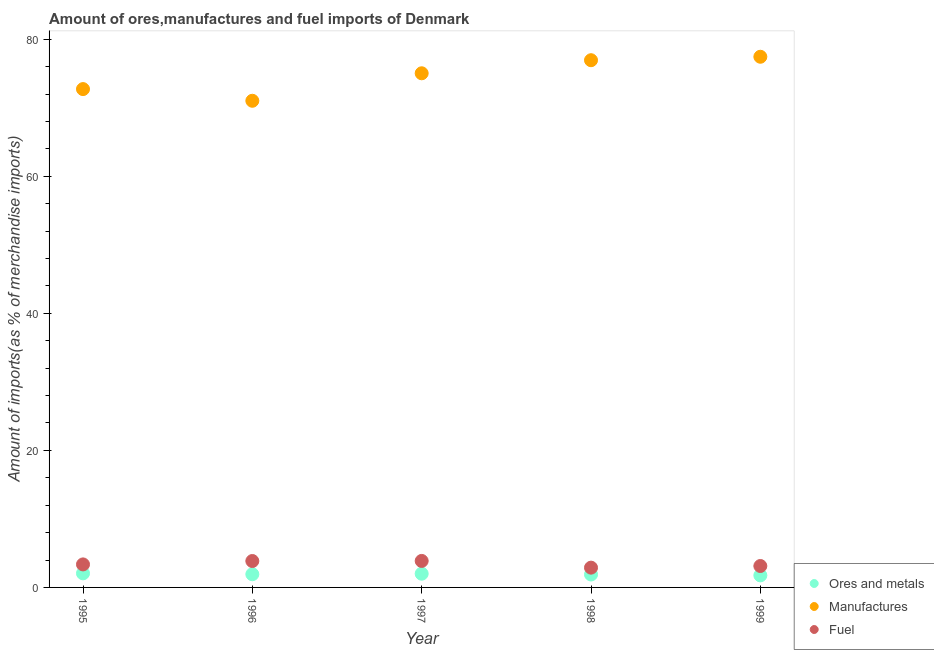What is the percentage of manufactures imports in 1997?
Ensure brevity in your answer.  75.02. Across all years, what is the maximum percentage of fuel imports?
Offer a terse response. 3.87. Across all years, what is the minimum percentage of manufactures imports?
Keep it short and to the point. 71.01. In which year was the percentage of fuel imports maximum?
Offer a terse response. 1997. What is the total percentage of manufactures imports in the graph?
Give a very brief answer. 373.12. What is the difference between the percentage of manufactures imports in 1995 and that in 1998?
Give a very brief answer. -4.21. What is the difference between the percentage of ores and metals imports in 1999 and the percentage of manufactures imports in 1995?
Your answer should be compact. -70.96. What is the average percentage of manufactures imports per year?
Your answer should be compact. 74.62. In the year 1999, what is the difference between the percentage of ores and metals imports and percentage of fuel imports?
Your answer should be very brief. -1.37. What is the ratio of the percentage of fuel imports in 1996 to that in 1997?
Offer a terse response. 1. What is the difference between the highest and the second highest percentage of manufactures imports?
Make the answer very short. 0.51. What is the difference between the highest and the lowest percentage of fuel imports?
Offer a terse response. 0.98. In how many years, is the percentage of fuel imports greater than the average percentage of fuel imports taken over all years?
Keep it short and to the point. 2. Is the sum of the percentage of fuel imports in 1996 and 1998 greater than the maximum percentage of manufactures imports across all years?
Ensure brevity in your answer.  No. Is it the case that in every year, the sum of the percentage of ores and metals imports and percentage of manufactures imports is greater than the percentage of fuel imports?
Your answer should be very brief. Yes. How many dotlines are there?
Give a very brief answer. 3. How many years are there in the graph?
Give a very brief answer. 5. Are the values on the major ticks of Y-axis written in scientific E-notation?
Make the answer very short. No. Does the graph contain grids?
Your answer should be very brief. No. How many legend labels are there?
Give a very brief answer. 3. What is the title of the graph?
Provide a short and direct response. Amount of ores,manufactures and fuel imports of Denmark. Does "Agriculture" appear as one of the legend labels in the graph?
Offer a terse response. No. What is the label or title of the Y-axis?
Your answer should be very brief. Amount of imports(as % of merchandise imports). What is the Amount of imports(as % of merchandise imports) of Ores and metals in 1995?
Your response must be concise. 2.05. What is the Amount of imports(as % of merchandise imports) in Manufactures in 1995?
Your answer should be very brief. 72.72. What is the Amount of imports(as % of merchandise imports) of Fuel in 1995?
Keep it short and to the point. 3.36. What is the Amount of imports(as % of merchandise imports) in Ores and metals in 1996?
Provide a succinct answer. 1.92. What is the Amount of imports(as % of merchandise imports) of Manufactures in 1996?
Provide a succinct answer. 71.01. What is the Amount of imports(as % of merchandise imports) in Fuel in 1996?
Offer a very short reply. 3.85. What is the Amount of imports(as % of merchandise imports) of Ores and metals in 1997?
Your response must be concise. 2. What is the Amount of imports(as % of merchandise imports) of Manufactures in 1997?
Offer a very short reply. 75.02. What is the Amount of imports(as % of merchandise imports) of Fuel in 1997?
Your answer should be very brief. 3.87. What is the Amount of imports(as % of merchandise imports) in Ores and metals in 1998?
Offer a very short reply. 1.89. What is the Amount of imports(as % of merchandise imports) in Manufactures in 1998?
Offer a terse response. 76.93. What is the Amount of imports(as % of merchandise imports) of Fuel in 1998?
Offer a very short reply. 2.89. What is the Amount of imports(as % of merchandise imports) in Ores and metals in 1999?
Make the answer very short. 1.76. What is the Amount of imports(as % of merchandise imports) in Manufactures in 1999?
Provide a succinct answer. 77.44. What is the Amount of imports(as % of merchandise imports) in Fuel in 1999?
Make the answer very short. 3.12. Across all years, what is the maximum Amount of imports(as % of merchandise imports) of Ores and metals?
Offer a very short reply. 2.05. Across all years, what is the maximum Amount of imports(as % of merchandise imports) in Manufactures?
Offer a very short reply. 77.44. Across all years, what is the maximum Amount of imports(as % of merchandise imports) in Fuel?
Your answer should be compact. 3.87. Across all years, what is the minimum Amount of imports(as % of merchandise imports) in Ores and metals?
Your response must be concise. 1.76. Across all years, what is the minimum Amount of imports(as % of merchandise imports) of Manufactures?
Offer a terse response. 71.01. Across all years, what is the minimum Amount of imports(as % of merchandise imports) in Fuel?
Provide a short and direct response. 2.89. What is the total Amount of imports(as % of merchandise imports) of Ores and metals in the graph?
Provide a short and direct response. 9.62. What is the total Amount of imports(as % of merchandise imports) in Manufactures in the graph?
Give a very brief answer. 373.12. What is the total Amount of imports(as % of merchandise imports) in Fuel in the graph?
Provide a succinct answer. 17.09. What is the difference between the Amount of imports(as % of merchandise imports) of Ores and metals in 1995 and that in 1996?
Make the answer very short. 0.13. What is the difference between the Amount of imports(as % of merchandise imports) of Manufactures in 1995 and that in 1996?
Your answer should be compact. 1.71. What is the difference between the Amount of imports(as % of merchandise imports) of Fuel in 1995 and that in 1996?
Give a very brief answer. -0.49. What is the difference between the Amount of imports(as % of merchandise imports) of Ores and metals in 1995 and that in 1997?
Ensure brevity in your answer.  0.05. What is the difference between the Amount of imports(as % of merchandise imports) of Manufactures in 1995 and that in 1997?
Offer a very short reply. -2.31. What is the difference between the Amount of imports(as % of merchandise imports) of Fuel in 1995 and that in 1997?
Make the answer very short. -0.51. What is the difference between the Amount of imports(as % of merchandise imports) of Ores and metals in 1995 and that in 1998?
Provide a short and direct response. 0.17. What is the difference between the Amount of imports(as % of merchandise imports) of Manufactures in 1995 and that in 1998?
Give a very brief answer. -4.21. What is the difference between the Amount of imports(as % of merchandise imports) in Fuel in 1995 and that in 1998?
Ensure brevity in your answer.  0.47. What is the difference between the Amount of imports(as % of merchandise imports) of Ores and metals in 1995 and that in 1999?
Give a very brief answer. 0.29. What is the difference between the Amount of imports(as % of merchandise imports) of Manufactures in 1995 and that in 1999?
Offer a very short reply. -4.72. What is the difference between the Amount of imports(as % of merchandise imports) in Fuel in 1995 and that in 1999?
Give a very brief answer. 0.23. What is the difference between the Amount of imports(as % of merchandise imports) in Ores and metals in 1996 and that in 1997?
Offer a terse response. -0.08. What is the difference between the Amount of imports(as % of merchandise imports) in Manufactures in 1996 and that in 1997?
Your answer should be very brief. -4.01. What is the difference between the Amount of imports(as % of merchandise imports) of Fuel in 1996 and that in 1997?
Ensure brevity in your answer.  -0.01. What is the difference between the Amount of imports(as % of merchandise imports) in Ores and metals in 1996 and that in 1998?
Your response must be concise. 0.04. What is the difference between the Amount of imports(as % of merchandise imports) of Manufactures in 1996 and that in 1998?
Give a very brief answer. -5.92. What is the difference between the Amount of imports(as % of merchandise imports) of Fuel in 1996 and that in 1998?
Offer a terse response. 0.97. What is the difference between the Amount of imports(as % of merchandise imports) of Ores and metals in 1996 and that in 1999?
Your answer should be very brief. 0.16. What is the difference between the Amount of imports(as % of merchandise imports) of Manufactures in 1996 and that in 1999?
Offer a very short reply. -6.42. What is the difference between the Amount of imports(as % of merchandise imports) of Fuel in 1996 and that in 1999?
Keep it short and to the point. 0.73. What is the difference between the Amount of imports(as % of merchandise imports) of Ores and metals in 1997 and that in 1998?
Provide a succinct answer. 0.12. What is the difference between the Amount of imports(as % of merchandise imports) in Manufactures in 1997 and that in 1998?
Make the answer very short. -1.91. What is the difference between the Amount of imports(as % of merchandise imports) of Fuel in 1997 and that in 1998?
Provide a succinct answer. 0.98. What is the difference between the Amount of imports(as % of merchandise imports) of Ores and metals in 1997 and that in 1999?
Provide a short and direct response. 0.24. What is the difference between the Amount of imports(as % of merchandise imports) of Manufactures in 1997 and that in 1999?
Provide a succinct answer. -2.41. What is the difference between the Amount of imports(as % of merchandise imports) in Fuel in 1997 and that in 1999?
Your answer should be very brief. 0.74. What is the difference between the Amount of imports(as % of merchandise imports) of Ores and metals in 1998 and that in 1999?
Offer a terse response. 0.13. What is the difference between the Amount of imports(as % of merchandise imports) in Manufactures in 1998 and that in 1999?
Your response must be concise. -0.51. What is the difference between the Amount of imports(as % of merchandise imports) of Fuel in 1998 and that in 1999?
Make the answer very short. -0.24. What is the difference between the Amount of imports(as % of merchandise imports) of Ores and metals in 1995 and the Amount of imports(as % of merchandise imports) of Manufactures in 1996?
Offer a terse response. -68.96. What is the difference between the Amount of imports(as % of merchandise imports) in Ores and metals in 1995 and the Amount of imports(as % of merchandise imports) in Fuel in 1996?
Offer a terse response. -1.8. What is the difference between the Amount of imports(as % of merchandise imports) in Manufactures in 1995 and the Amount of imports(as % of merchandise imports) in Fuel in 1996?
Give a very brief answer. 68.86. What is the difference between the Amount of imports(as % of merchandise imports) of Ores and metals in 1995 and the Amount of imports(as % of merchandise imports) of Manufactures in 1997?
Keep it short and to the point. -72.97. What is the difference between the Amount of imports(as % of merchandise imports) of Ores and metals in 1995 and the Amount of imports(as % of merchandise imports) of Fuel in 1997?
Provide a succinct answer. -1.81. What is the difference between the Amount of imports(as % of merchandise imports) of Manufactures in 1995 and the Amount of imports(as % of merchandise imports) of Fuel in 1997?
Keep it short and to the point. 68.85. What is the difference between the Amount of imports(as % of merchandise imports) in Ores and metals in 1995 and the Amount of imports(as % of merchandise imports) in Manufactures in 1998?
Provide a short and direct response. -74.88. What is the difference between the Amount of imports(as % of merchandise imports) of Ores and metals in 1995 and the Amount of imports(as % of merchandise imports) of Fuel in 1998?
Keep it short and to the point. -0.83. What is the difference between the Amount of imports(as % of merchandise imports) in Manufactures in 1995 and the Amount of imports(as % of merchandise imports) in Fuel in 1998?
Keep it short and to the point. 69.83. What is the difference between the Amount of imports(as % of merchandise imports) of Ores and metals in 1995 and the Amount of imports(as % of merchandise imports) of Manufactures in 1999?
Provide a succinct answer. -75.38. What is the difference between the Amount of imports(as % of merchandise imports) of Ores and metals in 1995 and the Amount of imports(as % of merchandise imports) of Fuel in 1999?
Give a very brief answer. -1.07. What is the difference between the Amount of imports(as % of merchandise imports) in Manufactures in 1995 and the Amount of imports(as % of merchandise imports) in Fuel in 1999?
Offer a very short reply. 69.59. What is the difference between the Amount of imports(as % of merchandise imports) of Ores and metals in 1996 and the Amount of imports(as % of merchandise imports) of Manufactures in 1997?
Keep it short and to the point. -73.1. What is the difference between the Amount of imports(as % of merchandise imports) of Ores and metals in 1996 and the Amount of imports(as % of merchandise imports) of Fuel in 1997?
Your response must be concise. -1.94. What is the difference between the Amount of imports(as % of merchandise imports) of Manufactures in 1996 and the Amount of imports(as % of merchandise imports) of Fuel in 1997?
Offer a terse response. 67.15. What is the difference between the Amount of imports(as % of merchandise imports) in Ores and metals in 1996 and the Amount of imports(as % of merchandise imports) in Manufactures in 1998?
Give a very brief answer. -75.01. What is the difference between the Amount of imports(as % of merchandise imports) of Ores and metals in 1996 and the Amount of imports(as % of merchandise imports) of Fuel in 1998?
Offer a very short reply. -0.96. What is the difference between the Amount of imports(as % of merchandise imports) in Manufactures in 1996 and the Amount of imports(as % of merchandise imports) in Fuel in 1998?
Provide a short and direct response. 68.13. What is the difference between the Amount of imports(as % of merchandise imports) of Ores and metals in 1996 and the Amount of imports(as % of merchandise imports) of Manufactures in 1999?
Offer a very short reply. -75.51. What is the difference between the Amount of imports(as % of merchandise imports) of Ores and metals in 1996 and the Amount of imports(as % of merchandise imports) of Fuel in 1999?
Offer a very short reply. -1.2. What is the difference between the Amount of imports(as % of merchandise imports) of Manufactures in 1996 and the Amount of imports(as % of merchandise imports) of Fuel in 1999?
Keep it short and to the point. 67.89. What is the difference between the Amount of imports(as % of merchandise imports) of Ores and metals in 1997 and the Amount of imports(as % of merchandise imports) of Manufactures in 1998?
Keep it short and to the point. -74.93. What is the difference between the Amount of imports(as % of merchandise imports) of Ores and metals in 1997 and the Amount of imports(as % of merchandise imports) of Fuel in 1998?
Make the answer very short. -0.89. What is the difference between the Amount of imports(as % of merchandise imports) in Manufactures in 1997 and the Amount of imports(as % of merchandise imports) in Fuel in 1998?
Your answer should be very brief. 72.14. What is the difference between the Amount of imports(as % of merchandise imports) of Ores and metals in 1997 and the Amount of imports(as % of merchandise imports) of Manufactures in 1999?
Provide a succinct answer. -75.43. What is the difference between the Amount of imports(as % of merchandise imports) of Ores and metals in 1997 and the Amount of imports(as % of merchandise imports) of Fuel in 1999?
Your answer should be compact. -1.12. What is the difference between the Amount of imports(as % of merchandise imports) of Manufactures in 1997 and the Amount of imports(as % of merchandise imports) of Fuel in 1999?
Provide a succinct answer. 71.9. What is the difference between the Amount of imports(as % of merchandise imports) of Ores and metals in 1998 and the Amount of imports(as % of merchandise imports) of Manufactures in 1999?
Make the answer very short. -75.55. What is the difference between the Amount of imports(as % of merchandise imports) of Ores and metals in 1998 and the Amount of imports(as % of merchandise imports) of Fuel in 1999?
Offer a terse response. -1.24. What is the difference between the Amount of imports(as % of merchandise imports) in Manufactures in 1998 and the Amount of imports(as % of merchandise imports) in Fuel in 1999?
Give a very brief answer. 73.81. What is the average Amount of imports(as % of merchandise imports) of Ores and metals per year?
Provide a succinct answer. 1.92. What is the average Amount of imports(as % of merchandise imports) in Manufactures per year?
Your response must be concise. 74.62. What is the average Amount of imports(as % of merchandise imports) in Fuel per year?
Offer a very short reply. 3.42. In the year 1995, what is the difference between the Amount of imports(as % of merchandise imports) in Ores and metals and Amount of imports(as % of merchandise imports) in Manufactures?
Make the answer very short. -70.66. In the year 1995, what is the difference between the Amount of imports(as % of merchandise imports) of Ores and metals and Amount of imports(as % of merchandise imports) of Fuel?
Ensure brevity in your answer.  -1.3. In the year 1995, what is the difference between the Amount of imports(as % of merchandise imports) of Manufactures and Amount of imports(as % of merchandise imports) of Fuel?
Offer a very short reply. 69.36. In the year 1996, what is the difference between the Amount of imports(as % of merchandise imports) of Ores and metals and Amount of imports(as % of merchandise imports) of Manufactures?
Offer a terse response. -69.09. In the year 1996, what is the difference between the Amount of imports(as % of merchandise imports) of Ores and metals and Amount of imports(as % of merchandise imports) of Fuel?
Provide a succinct answer. -1.93. In the year 1996, what is the difference between the Amount of imports(as % of merchandise imports) in Manufactures and Amount of imports(as % of merchandise imports) in Fuel?
Offer a very short reply. 67.16. In the year 1997, what is the difference between the Amount of imports(as % of merchandise imports) in Ores and metals and Amount of imports(as % of merchandise imports) in Manufactures?
Offer a terse response. -73.02. In the year 1997, what is the difference between the Amount of imports(as % of merchandise imports) of Ores and metals and Amount of imports(as % of merchandise imports) of Fuel?
Offer a terse response. -1.87. In the year 1997, what is the difference between the Amount of imports(as % of merchandise imports) of Manufactures and Amount of imports(as % of merchandise imports) of Fuel?
Provide a succinct answer. 71.16. In the year 1998, what is the difference between the Amount of imports(as % of merchandise imports) of Ores and metals and Amount of imports(as % of merchandise imports) of Manufactures?
Provide a short and direct response. -75.04. In the year 1998, what is the difference between the Amount of imports(as % of merchandise imports) in Ores and metals and Amount of imports(as % of merchandise imports) in Fuel?
Offer a very short reply. -1. In the year 1998, what is the difference between the Amount of imports(as % of merchandise imports) in Manufactures and Amount of imports(as % of merchandise imports) in Fuel?
Offer a very short reply. 74.04. In the year 1999, what is the difference between the Amount of imports(as % of merchandise imports) of Ores and metals and Amount of imports(as % of merchandise imports) of Manufactures?
Your response must be concise. -75.68. In the year 1999, what is the difference between the Amount of imports(as % of merchandise imports) of Ores and metals and Amount of imports(as % of merchandise imports) of Fuel?
Your answer should be very brief. -1.37. In the year 1999, what is the difference between the Amount of imports(as % of merchandise imports) in Manufactures and Amount of imports(as % of merchandise imports) in Fuel?
Your answer should be compact. 74.31. What is the ratio of the Amount of imports(as % of merchandise imports) in Ores and metals in 1995 to that in 1996?
Ensure brevity in your answer.  1.07. What is the ratio of the Amount of imports(as % of merchandise imports) in Manufactures in 1995 to that in 1996?
Give a very brief answer. 1.02. What is the ratio of the Amount of imports(as % of merchandise imports) in Fuel in 1995 to that in 1996?
Ensure brevity in your answer.  0.87. What is the ratio of the Amount of imports(as % of merchandise imports) of Ores and metals in 1995 to that in 1997?
Your response must be concise. 1.03. What is the ratio of the Amount of imports(as % of merchandise imports) of Manufactures in 1995 to that in 1997?
Ensure brevity in your answer.  0.97. What is the ratio of the Amount of imports(as % of merchandise imports) in Fuel in 1995 to that in 1997?
Your answer should be compact. 0.87. What is the ratio of the Amount of imports(as % of merchandise imports) in Ores and metals in 1995 to that in 1998?
Your response must be concise. 1.09. What is the ratio of the Amount of imports(as % of merchandise imports) in Manufactures in 1995 to that in 1998?
Your answer should be compact. 0.95. What is the ratio of the Amount of imports(as % of merchandise imports) in Fuel in 1995 to that in 1998?
Make the answer very short. 1.16. What is the ratio of the Amount of imports(as % of merchandise imports) in Ores and metals in 1995 to that in 1999?
Offer a terse response. 1.17. What is the ratio of the Amount of imports(as % of merchandise imports) of Manufactures in 1995 to that in 1999?
Your answer should be very brief. 0.94. What is the ratio of the Amount of imports(as % of merchandise imports) of Fuel in 1995 to that in 1999?
Provide a short and direct response. 1.07. What is the ratio of the Amount of imports(as % of merchandise imports) in Ores and metals in 1996 to that in 1997?
Offer a very short reply. 0.96. What is the ratio of the Amount of imports(as % of merchandise imports) in Manufactures in 1996 to that in 1997?
Provide a short and direct response. 0.95. What is the ratio of the Amount of imports(as % of merchandise imports) in Fuel in 1996 to that in 1997?
Your response must be concise. 1. What is the ratio of the Amount of imports(as % of merchandise imports) of Ores and metals in 1996 to that in 1998?
Ensure brevity in your answer.  1.02. What is the ratio of the Amount of imports(as % of merchandise imports) in Fuel in 1996 to that in 1998?
Your answer should be very brief. 1.34. What is the ratio of the Amount of imports(as % of merchandise imports) of Ores and metals in 1996 to that in 1999?
Offer a very short reply. 1.09. What is the ratio of the Amount of imports(as % of merchandise imports) of Manufactures in 1996 to that in 1999?
Ensure brevity in your answer.  0.92. What is the ratio of the Amount of imports(as % of merchandise imports) of Fuel in 1996 to that in 1999?
Provide a short and direct response. 1.23. What is the ratio of the Amount of imports(as % of merchandise imports) in Ores and metals in 1997 to that in 1998?
Provide a short and direct response. 1.06. What is the ratio of the Amount of imports(as % of merchandise imports) in Manufactures in 1997 to that in 1998?
Provide a succinct answer. 0.98. What is the ratio of the Amount of imports(as % of merchandise imports) in Fuel in 1997 to that in 1998?
Give a very brief answer. 1.34. What is the ratio of the Amount of imports(as % of merchandise imports) in Ores and metals in 1997 to that in 1999?
Offer a terse response. 1.14. What is the ratio of the Amount of imports(as % of merchandise imports) in Manufactures in 1997 to that in 1999?
Provide a succinct answer. 0.97. What is the ratio of the Amount of imports(as % of merchandise imports) in Fuel in 1997 to that in 1999?
Make the answer very short. 1.24. What is the ratio of the Amount of imports(as % of merchandise imports) of Ores and metals in 1998 to that in 1999?
Provide a succinct answer. 1.07. What is the ratio of the Amount of imports(as % of merchandise imports) of Manufactures in 1998 to that in 1999?
Offer a terse response. 0.99. What is the ratio of the Amount of imports(as % of merchandise imports) in Fuel in 1998 to that in 1999?
Ensure brevity in your answer.  0.92. What is the difference between the highest and the second highest Amount of imports(as % of merchandise imports) in Ores and metals?
Provide a succinct answer. 0.05. What is the difference between the highest and the second highest Amount of imports(as % of merchandise imports) of Manufactures?
Your response must be concise. 0.51. What is the difference between the highest and the second highest Amount of imports(as % of merchandise imports) of Fuel?
Your answer should be compact. 0.01. What is the difference between the highest and the lowest Amount of imports(as % of merchandise imports) in Ores and metals?
Give a very brief answer. 0.29. What is the difference between the highest and the lowest Amount of imports(as % of merchandise imports) of Manufactures?
Offer a terse response. 6.42. What is the difference between the highest and the lowest Amount of imports(as % of merchandise imports) of Fuel?
Your answer should be very brief. 0.98. 